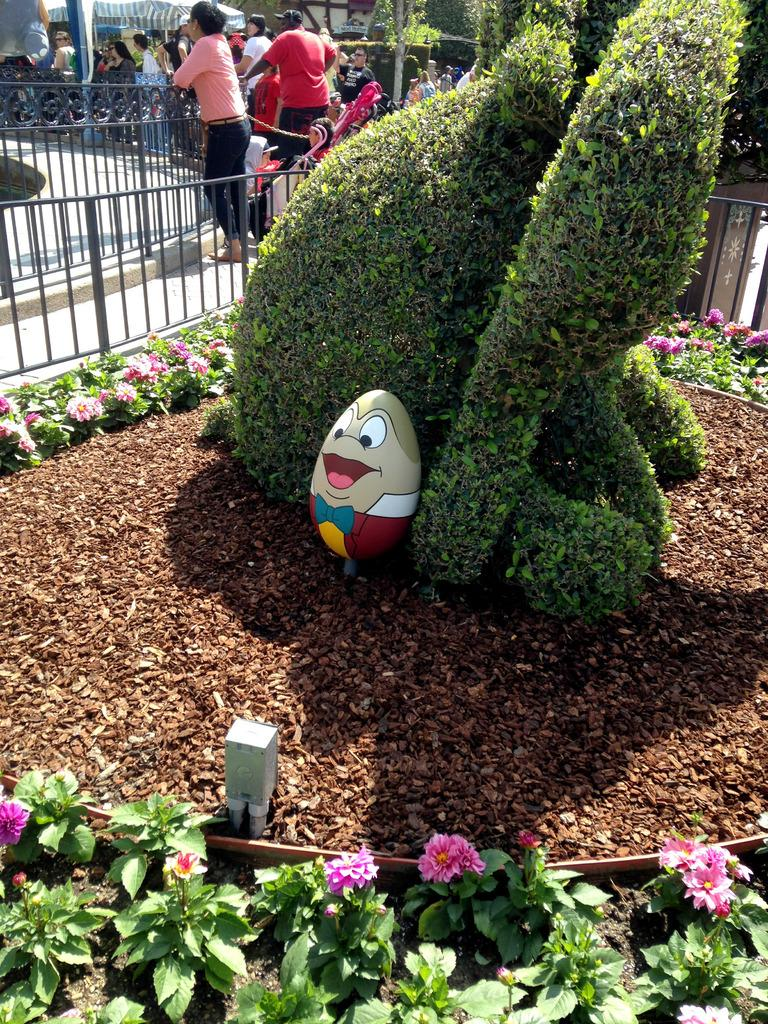What type of vegetation is present in the image? There are flowers on the plants in the image. What can be seen in the background of the image? There is a rail in the background of the image. Are there any living beings visible in the image? Yes, there are people visible in the image. What type of icicle can be seen hanging from the rail in the image? There is no icicle present in the image; it is not cold enough for icicles to form. 